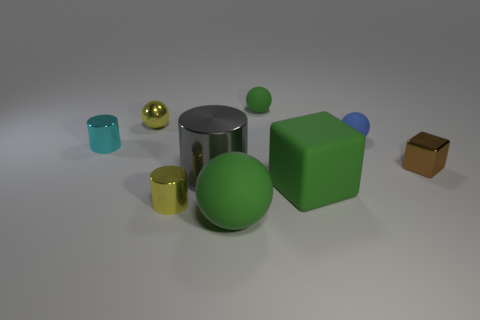How many green balls must be subtracted to get 1 green balls? 1 Subtract all purple cylinders. Subtract all blue spheres. How many cylinders are left? 3 Add 1 blue things. How many objects exist? 10 Subtract all cylinders. How many objects are left? 6 Subtract all cyan cylinders. Subtract all green rubber objects. How many objects are left? 5 Add 7 large matte blocks. How many large matte blocks are left? 8 Add 9 gray shiny things. How many gray shiny things exist? 10 Subtract 0 purple balls. How many objects are left? 9 